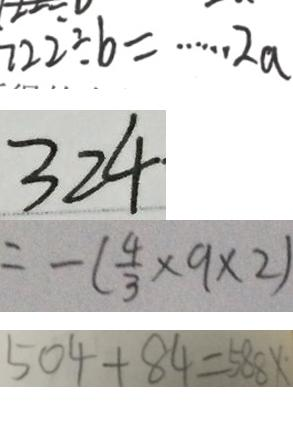Convert formula to latex. <formula><loc_0><loc_0><loc_500><loc_500>7 2 2 \div b = \cdots 2 a 
 3 2 4 
 = - ( \frac { 4 } { 3 } \times 9 \times 2 ) 
 5 0 4 + 8 4 = 5 8 8 x</formula> 